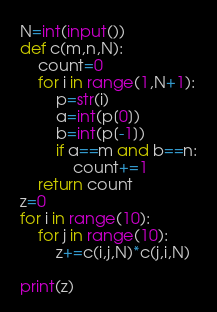<code> <loc_0><loc_0><loc_500><loc_500><_Python_>N=int(input())
def c(m,n,N):
    count=0
    for i in range(1,N+1):
        p=str(i)
        a=int(p[0])
        b=int(p[-1])
        if a==m and b==n:
            count+=1
    return count
z=0
for i in range(10):
    for j in range(10):
        z+=c(i,j,N)*c(j,i,N)

print(z)</code> 